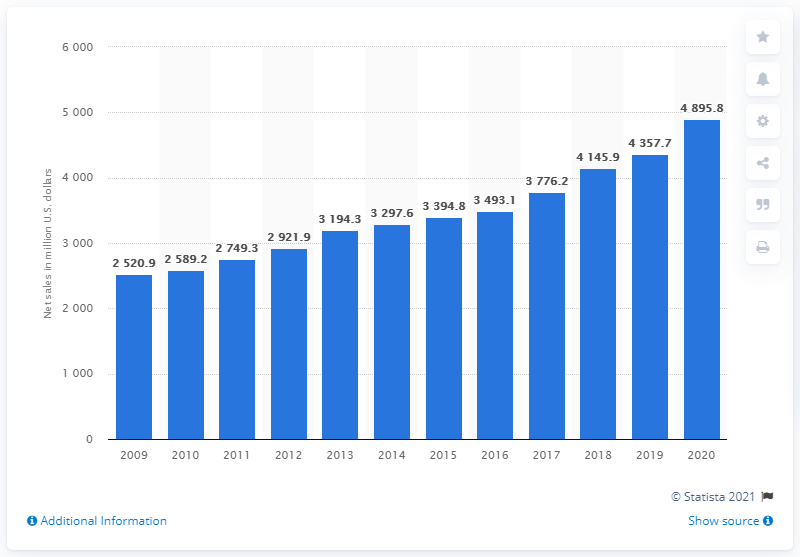Point out several critical features in this image. Church & Dwight's global net sales in dollars for the year 2020 were approximately $48,958,000. 